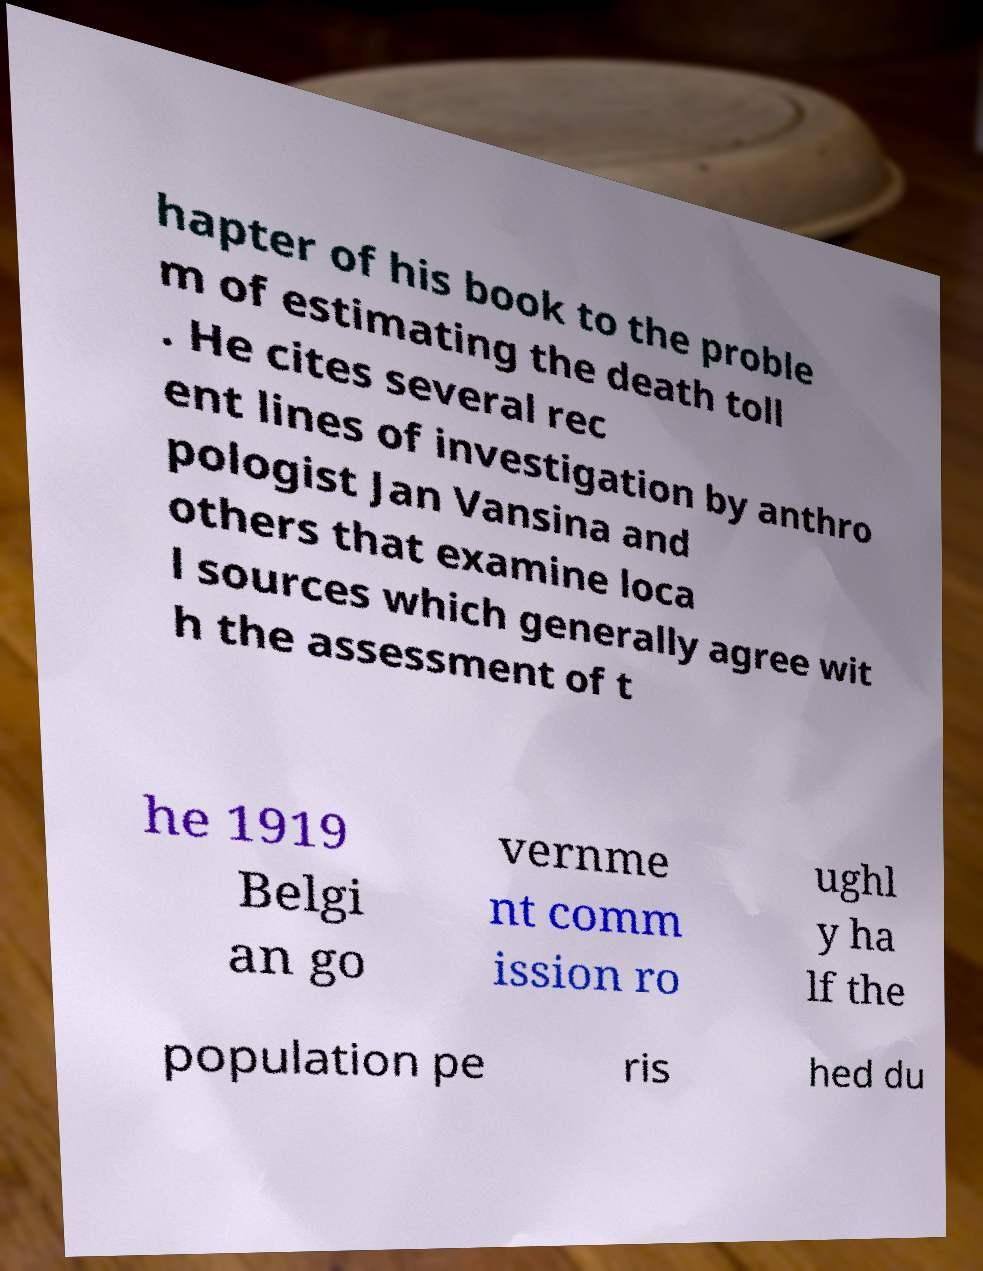Can you accurately transcribe the text from the provided image for me? hapter of his book to the proble m of estimating the death toll . He cites several rec ent lines of investigation by anthro pologist Jan Vansina and others that examine loca l sources which generally agree wit h the assessment of t he 1919 Belgi an go vernme nt comm ission ro ughl y ha lf the population pe ris hed du 